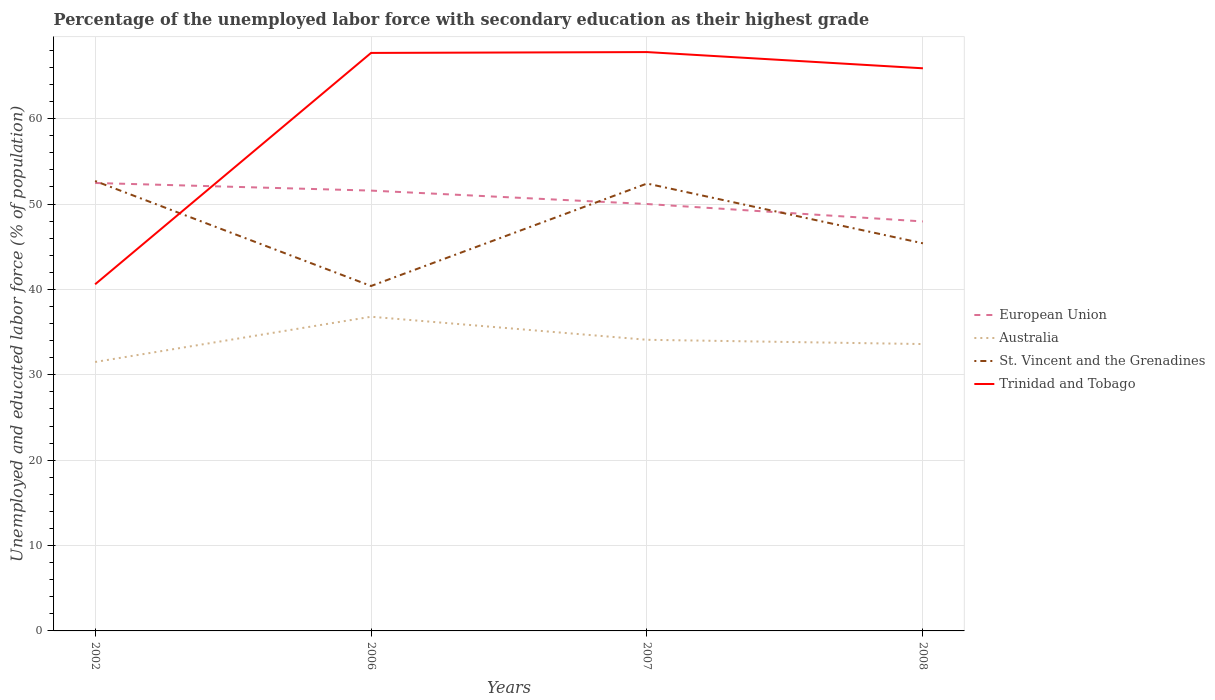Is the number of lines equal to the number of legend labels?
Ensure brevity in your answer.  Yes. Across all years, what is the maximum percentage of the unemployed labor force with secondary education in Australia?
Your answer should be very brief. 31.5. What is the total percentage of the unemployed labor force with secondary education in Trinidad and Tobago in the graph?
Offer a terse response. -27.2. What is the difference between the highest and the second highest percentage of the unemployed labor force with secondary education in Trinidad and Tobago?
Your answer should be compact. 27.2. What is the difference between the highest and the lowest percentage of the unemployed labor force with secondary education in Australia?
Ensure brevity in your answer.  2. Are the values on the major ticks of Y-axis written in scientific E-notation?
Offer a terse response. No. Does the graph contain any zero values?
Provide a succinct answer. No. Does the graph contain grids?
Provide a short and direct response. Yes. Where does the legend appear in the graph?
Your answer should be very brief. Center right. How many legend labels are there?
Offer a terse response. 4. How are the legend labels stacked?
Your answer should be very brief. Vertical. What is the title of the graph?
Your answer should be very brief. Percentage of the unemployed labor force with secondary education as their highest grade. Does "Iran" appear as one of the legend labels in the graph?
Offer a very short reply. No. What is the label or title of the Y-axis?
Your response must be concise. Unemployed and educated labor force (% of population). What is the Unemployed and educated labor force (% of population) of European Union in 2002?
Offer a very short reply. 52.47. What is the Unemployed and educated labor force (% of population) in Australia in 2002?
Provide a succinct answer. 31.5. What is the Unemployed and educated labor force (% of population) in St. Vincent and the Grenadines in 2002?
Provide a short and direct response. 52.7. What is the Unemployed and educated labor force (% of population) in Trinidad and Tobago in 2002?
Provide a succinct answer. 40.6. What is the Unemployed and educated labor force (% of population) of European Union in 2006?
Provide a short and direct response. 51.57. What is the Unemployed and educated labor force (% of population) in Australia in 2006?
Give a very brief answer. 36.8. What is the Unemployed and educated labor force (% of population) in St. Vincent and the Grenadines in 2006?
Keep it short and to the point. 40.4. What is the Unemployed and educated labor force (% of population) of Trinidad and Tobago in 2006?
Your answer should be compact. 67.7. What is the Unemployed and educated labor force (% of population) of European Union in 2007?
Your answer should be very brief. 50. What is the Unemployed and educated labor force (% of population) of Australia in 2007?
Provide a succinct answer. 34.1. What is the Unemployed and educated labor force (% of population) of St. Vincent and the Grenadines in 2007?
Offer a terse response. 52.4. What is the Unemployed and educated labor force (% of population) in Trinidad and Tobago in 2007?
Give a very brief answer. 67.8. What is the Unemployed and educated labor force (% of population) in European Union in 2008?
Offer a terse response. 47.96. What is the Unemployed and educated labor force (% of population) in Australia in 2008?
Make the answer very short. 33.6. What is the Unemployed and educated labor force (% of population) of St. Vincent and the Grenadines in 2008?
Your answer should be compact. 45.4. What is the Unemployed and educated labor force (% of population) in Trinidad and Tobago in 2008?
Your response must be concise. 65.9. Across all years, what is the maximum Unemployed and educated labor force (% of population) of European Union?
Keep it short and to the point. 52.47. Across all years, what is the maximum Unemployed and educated labor force (% of population) in Australia?
Your response must be concise. 36.8. Across all years, what is the maximum Unemployed and educated labor force (% of population) in St. Vincent and the Grenadines?
Provide a succinct answer. 52.7. Across all years, what is the maximum Unemployed and educated labor force (% of population) in Trinidad and Tobago?
Provide a succinct answer. 67.8. Across all years, what is the minimum Unemployed and educated labor force (% of population) in European Union?
Ensure brevity in your answer.  47.96. Across all years, what is the minimum Unemployed and educated labor force (% of population) of Australia?
Offer a very short reply. 31.5. Across all years, what is the minimum Unemployed and educated labor force (% of population) of St. Vincent and the Grenadines?
Offer a very short reply. 40.4. Across all years, what is the minimum Unemployed and educated labor force (% of population) in Trinidad and Tobago?
Your response must be concise. 40.6. What is the total Unemployed and educated labor force (% of population) in European Union in the graph?
Your response must be concise. 202. What is the total Unemployed and educated labor force (% of population) in Australia in the graph?
Make the answer very short. 136. What is the total Unemployed and educated labor force (% of population) of St. Vincent and the Grenadines in the graph?
Your answer should be very brief. 190.9. What is the total Unemployed and educated labor force (% of population) of Trinidad and Tobago in the graph?
Ensure brevity in your answer.  242. What is the difference between the Unemployed and educated labor force (% of population) in European Union in 2002 and that in 2006?
Offer a very short reply. 0.89. What is the difference between the Unemployed and educated labor force (% of population) in Trinidad and Tobago in 2002 and that in 2006?
Your answer should be compact. -27.1. What is the difference between the Unemployed and educated labor force (% of population) of European Union in 2002 and that in 2007?
Keep it short and to the point. 2.46. What is the difference between the Unemployed and educated labor force (% of population) in Trinidad and Tobago in 2002 and that in 2007?
Give a very brief answer. -27.2. What is the difference between the Unemployed and educated labor force (% of population) of European Union in 2002 and that in 2008?
Your response must be concise. 4.5. What is the difference between the Unemployed and educated labor force (% of population) in Australia in 2002 and that in 2008?
Offer a very short reply. -2.1. What is the difference between the Unemployed and educated labor force (% of population) in Trinidad and Tobago in 2002 and that in 2008?
Offer a very short reply. -25.3. What is the difference between the Unemployed and educated labor force (% of population) in European Union in 2006 and that in 2007?
Make the answer very short. 1.57. What is the difference between the Unemployed and educated labor force (% of population) of Australia in 2006 and that in 2007?
Ensure brevity in your answer.  2.7. What is the difference between the Unemployed and educated labor force (% of population) in Trinidad and Tobago in 2006 and that in 2007?
Your answer should be very brief. -0.1. What is the difference between the Unemployed and educated labor force (% of population) of European Union in 2006 and that in 2008?
Provide a short and direct response. 3.61. What is the difference between the Unemployed and educated labor force (% of population) of Australia in 2006 and that in 2008?
Offer a terse response. 3.2. What is the difference between the Unemployed and educated labor force (% of population) of European Union in 2007 and that in 2008?
Offer a terse response. 2.04. What is the difference between the Unemployed and educated labor force (% of population) of Australia in 2007 and that in 2008?
Your answer should be very brief. 0.5. What is the difference between the Unemployed and educated labor force (% of population) of Trinidad and Tobago in 2007 and that in 2008?
Offer a very short reply. 1.9. What is the difference between the Unemployed and educated labor force (% of population) of European Union in 2002 and the Unemployed and educated labor force (% of population) of Australia in 2006?
Offer a terse response. 15.67. What is the difference between the Unemployed and educated labor force (% of population) in European Union in 2002 and the Unemployed and educated labor force (% of population) in St. Vincent and the Grenadines in 2006?
Your response must be concise. 12.07. What is the difference between the Unemployed and educated labor force (% of population) in European Union in 2002 and the Unemployed and educated labor force (% of population) in Trinidad and Tobago in 2006?
Provide a succinct answer. -15.23. What is the difference between the Unemployed and educated labor force (% of population) of Australia in 2002 and the Unemployed and educated labor force (% of population) of St. Vincent and the Grenadines in 2006?
Keep it short and to the point. -8.9. What is the difference between the Unemployed and educated labor force (% of population) of Australia in 2002 and the Unemployed and educated labor force (% of population) of Trinidad and Tobago in 2006?
Give a very brief answer. -36.2. What is the difference between the Unemployed and educated labor force (% of population) of St. Vincent and the Grenadines in 2002 and the Unemployed and educated labor force (% of population) of Trinidad and Tobago in 2006?
Offer a very short reply. -15. What is the difference between the Unemployed and educated labor force (% of population) of European Union in 2002 and the Unemployed and educated labor force (% of population) of Australia in 2007?
Your answer should be very brief. 18.37. What is the difference between the Unemployed and educated labor force (% of population) in European Union in 2002 and the Unemployed and educated labor force (% of population) in St. Vincent and the Grenadines in 2007?
Your answer should be compact. 0.07. What is the difference between the Unemployed and educated labor force (% of population) in European Union in 2002 and the Unemployed and educated labor force (% of population) in Trinidad and Tobago in 2007?
Ensure brevity in your answer.  -15.33. What is the difference between the Unemployed and educated labor force (% of population) in Australia in 2002 and the Unemployed and educated labor force (% of population) in St. Vincent and the Grenadines in 2007?
Offer a very short reply. -20.9. What is the difference between the Unemployed and educated labor force (% of population) in Australia in 2002 and the Unemployed and educated labor force (% of population) in Trinidad and Tobago in 2007?
Your answer should be very brief. -36.3. What is the difference between the Unemployed and educated labor force (% of population) in St. Vincent and the Grenadines in 2002 and the Unemployed and educated labor force (% of population) in Trinidad and Tobago in 2007?
Offer a very short reply. -15.1. What is the difference between the Unemployed and educated labor force (% of population) in European Union in 2002 and the Unemployed and educated labor force (% of population) in Australia in 2008?
Your answer should be compact. 18.87. What is the difference between the Unemployed and educated labor force (% of population) in European Union in 2002 and the Unemployed and educated labor force (% of population) in St. Vincent and the Grenadines in 2008?
Your answer should be very brief. 7.07. What is the difference between the Unemployed and educated labor force (% of population) in European Union in 2002 and the Unemployed and educated labor force (% of population) in Trinidad and Tobago in 2008?
Ensure brevity in your answer.  -13.43. What is the difference between the Unemployed and educated labor force (% of population) of Australia in 2002 and the Unemployed and educated labor force (% of population) of St. Vincent and the Grenadines in 2008?
Provide a short and direct response. -13.9. What is the difference between the Unemployed and educated labor force (% of population) of Australia in 2002 and the Unemployed and educated labor force (% of population) of Trinidad and Tobago in 2008?
Make the answer very short. -34.4. What is the difference between the Unemployed and educated labor force (% of population) of St. Vincent and the Grenadines in 2002 and the Unemployed and educated labor force (% of population) of Trinidad and Tobago in 2008?
Your answer should be very brief. -13.2. What is the difference between the Unemployed and educated labor force (% of population) of European Union in 2006 and the Unemployed and educated labor force (% of population) of Australia in 2007?
Your answer should be compact. 17.47. What is the difference between the Unemployed and educated labor force (% of population) of European Union in 2006 and the Unemployed and educated labor force (% of population) of St. Vincent and the Grenadines in 2007?
Provide a short and direct response. -0.83. What is the difference between the Unemployed and educated labor force (% of population) in European Union in 2006 and the Unemployed and educated labor force (% of population) in Trinidad and Tobago in 2007?
Your response must be concise. -16.23. What is the difference between the Unemployed and educated labor force (% of population) of Australia in 2006 and the Unemployed and educated labor force (% of population) of St. Vincent and the Grenadines in 2007?
Your answer should be very brief. -15.6. What is the difference between the Unemployed and educated labor force (% of population) of Australia in 2006 and the Unemployed and educated labor force (% of population) of Trinidad and Tobago in 2007?
Keep it short and to the point. -31. What is the difference between the Unemployed and educated labor force (% of population) of St. Vincent and the Grenadines in 2006 and the Unemployed and educated labor force (% of population) of Trinidad and Tobago in 2007?
Your answer should be very brief. -27.4. What is the difference between the Unemployed and educated labor force (% of population) in European Union in 2006 and the Unemployed and educated labor force (% of population) in Australia in 2008?
Provide a succinct answer. 17.97. What is the difference between the Unemployed and educated labor force (% of population) in European Union in 2006 and the Unemployed and educated labor force (% of population) in St. Vincent and the Grenadines in 2008?
Provide a short and direct response. 6.17. What is the difference between the Unemployed and educated labor force (% of population) in European Union in 2006 and the Unemployed and educated labor force (% of population) in Trinidad and Tobago in 2008?
Offer a very short reply. -14.33. What is the difference between the Unemployed and educated labor force (% of population) of Australia in 2006 and the Unemployed and educated labor force (% of population) of Trinidad and Tobago in 2008?
Ensure brevity in your answer.  -29.1. What is the difference between the Unemployed and educated labor force (% of population) in St. Vincent and the Grenadines in 2006 and the Unemployed and educated labor force (% of population) in Trinidad and Tobago in 2008?
Give a very brief answer. -25.5. What is the difference between the Unemployed and educated labor force (% of population) of European Union in 2007 and the Unemployed and educated labor force (% of population) of Australia in 2008?
Offer a very short reply. 16.4. What is the difference between the Unemployed and educated labor force (% of population) in European Union in 2007 and the Unemployed and educated labor force (% of population) in St. Vincent and the Grenadines in 2008?
Your answer should be compact. 4.6. What is the difference between the Unemployed and educated labor force (% of population) of European Union in 2007 and the Unemployed and educated labor force (% of population) of Trinidad and Tobago in 2008?
Offer a very short reply. -15.9. What is the difference between the Unemployed and educated labor force (% of population) in Australia in 2007 and the Unemployed and educated labor force (% of population) in St. Vincent and the Grenadines in 2008?
Your answer should be compact. -11.3. What is the difference between the Unemployed and educated labor force (% of population) in Australia in 2007 and the Unemployed and educated labor force (% of population) in Trinidad and Tobago in 2008?
Give a very brief answer. -31.8. What is the difference between the Unemployed and educated labor force (% of population) of St. Vincent and the Grenadines in 2007 and the Unemployed and educated labor force (% of population) of Trinidad and Tobago in 2008?
Ensure brevity in your answer.  -13.5. What is the average Unemployed and educated labor force (% of population) of European Union per year?
Offer a terse response. 50.5. What is the average Unemployed and educated labor force (% of population) of St. Vincent and the Grenadines per year?
Make the answer very short. 47.73. What is the average Unemployed and educated labor force (% of population) of Trinidad and Tobago per year?
Offer a terse response. 60.5. In the year 2002, what is the difference between the Unemployed and educated labor force (% of population) in European Union and Unemployed and educated labor force (% of population) in Australia?
Give a very brief answer. 20.97. In the year 2002, what is the difference between the Unemployed and educated labor force (% of population) in European Union and Unemployed and educated labor force (% of population) in St. Vincent and the Grenadines?
Provide a succinct answer. -0.23. In the year 2002, what is the difference between the Unemployed and educated labor force (% of population) in European Union and Unemployed and educated labor force (% of population) in Trinidad and Tobago?
Ensure brevity in your answer.  11.87. In the year 2002, what is the difference between the Unemployed and educated labor force (% of population) of Australia and Unemployed and educated labor force (% of population) of St. Vincent and the Grenadines?
Ensure brevity in your answer.  -21.2. In the year 2002, what is the difference between the Unemployed and educated labor force (% of population) of St. Vincent and the Grenadines and Unemployed and educated labor force (% of population) of Trinidad and Tobago?
Give a very brief answer. 12.1. In the year 2006, what is the difference between the Unemployed and educated labor force (% of population) in European Union and Unemployed and educated labor force (% of population) in Australia?
Your answer should be very brief. 14.77. In the year 2006, what is the difference between the Unemployed and educated labor force (% of population) of European Union and Unemployed and educated labor force (% of population) of St. Vincent and the Grenadines?
Your response must be concise. 11.17. In the year 2006, what is the difference between the Unemployed and educated labor force (% of population) of European Union and Unemployed and educated labor force (% of population) of Trinidad and Tobago?
Ensure brevity in your answer.  -16.13. In the year 2006, what is the difference between the Unemployed and educated labor force (% of population) in Australia and Unemployed and educated labor force (% of population) in Trinidad and Tobago?
Your response must be concise. -30.9. In the year 2006, what is the difference between the Unemployed and educated labor force (% of population) in St. Vincent and the Grenadines and Unemployed and educated labor force (% of population) in Trinidad and Tobago?
Offer a very short reply. -27.3. In the year 2007, what is the difference between the Unemployed and educated labor force (% of population) of European Union and Unemployed and educated labor force (% of population) of Australia?
Give a very brief answer. 15.9. In the year 2007, what is the difference between the Unemployed and educated labor force (% of population) of European Union and Unemployed and educated labor force (% of population) of St. Vincent and the Grenadines?
Offer a very short reply. -2.4. In the year 2007, what is the difference between the Unemployed and educated labor force (% of population) in European Union and Unemployed and educated labor force (% of population) in Trinidad and Tobago?
Provide a succinct answer. -17.8. In the year 2007, what is the difference between the Unemployed and educated labor force (% of population) in Australia and Unemployed and educated labor force (% of population) in St. Vincent and the Grenadines?
Your response must be concise. -18.3. In the year 2007, what is the difference between the Unemployed and educated labor force (% of population) in Australia and Unemployed and educated labor force (% of population) in Trinidad and Tobago?
Give a very brief answer. -33.7. In the year 2007, what is the difference between the Unemployed and educated labor force (% of population) of St. Vincent and the Grenadines and Unemployed and educated labor force (% of population) of Trinidad and Tobago?
Make the answer very short. -15.4. In the year 2008, what is the difference between the Unemployed and educated labor force (% of population) in European Union and Unemployed and educated labor force (% of population) in Australia?
Ensure brevity in your answer.  14.36. In the year 2008, what is the difference between the Unemployed and educated labor force (% of population) in European Union and Unemployed and educated labor force (% of population) in St. Vincent and the Grenadines?
Your answer should be very brief. 2.56. In the year 2008, what is the difference between the Unemployed and educated labor force (% of population) of European Union and Unemployed and educated labor force (% of population) of Trinidad and Tobago?
Your answer should be very brief. -17.94. In the year 2008, what is the difference between the Unemployed and educated labor force (% of population) of Australia and Unemployed and educated labor force (% of population) of St. Vincent and the Grenadines?
Keep it short and to the point. -11.8. In the year 2008, what is the difference between the Unemployed and educated labor force (% of population) in Australia and Unemployed and educated labor force (% of population) in Trinidad and Tobago?
Ensure brevity in your answer.  -32.3. In the year 2008, what is the difference between the Unemployed and educated labor force (% of population) of St. Vincent and the Grenadines and Unemployed and educated labor force (% of population) of Trinidad and Tobago?
Your answer should be very brief. -20.5. What is the ratio of the Unemployed and educated labor force (% of population) of European Union in 2002 to that in 2006?
Your answer should be compact. 1.02. What is the ratio of the Unemployed and educated labor force (% of population) in Australia in 2002 to that in 2006?
Make the answer very short. 0.86. What is the ratio of the Unemployed and educated labor force (% of population) in St. Vincent and the Grenadines in 2002 to that in 2006?
Offer a very short reply. 1.3. What is the ratio of the Unemployed and educated labor force (% of population) in Trinidad and Tobago in 2002 to that in 2006?
Your answer should be compact. 0.6. What is the ratio of the Unemployed and educated labor force (% of population) in European Union in 2002 to that in 2007?
Offer a terse response. 1.05. What is the ratio of the Unemployed and educated labor force (% of population) in Australia in 2002 to that in 2007?
Offer a very short reply. 0.92. What is the ratio of the Unemployed and educated labor force (% of population) in St. Vincent and the Grenadines in 2002 to that in 2007?
Provide a succinct answer. 1.01. What is the ratio of the Unemployed and educated labor force (% of population) in Trinidad and Tobago in 2002 to that in 2007?
Make the answer very short. 0.6. What is the ratio of the Unemployed and educated labor force (% of population) in European Union in 2002 to that in 2008?
Make the answer very short. 1.09. What is the ratio of the Unemployed and educated labor force (% of population) in Australia in 2002 to that in 2008?
Make the answer very short. 0.94. What is the ratio of the Unemployed and educated labor force (% of population) in St. Vincent and the Grenadines in 2002 to that in 2008?
Your answer should be very brief. 1.16. What is the ratio of the Unemployed and educated labor force (% of population) in Trinidad and Tobago in 2002 to that in 2008?
Provide a short and direct response. 0.62. What is the ratio of the Unemployed and educated labor force (% of population) in European Union in 2006 to that in 2007?
Offer a very short reply. 1.03. What is the ratio of the Unemployed and educated labor force (% of population) of Australia in 2006 to that in 2007?
Offer a very short reply. 1.08. What is the ratio of the Unemployed and educated labor force (% of population) of St. Vincent and the Grenadines in 2006 to that in 2007?
Give a very brief answer. 0.77. What is the ratio of the Unemployed and educated labor force (% of population) in European Union in 2006 to that in 2008?
Ensure brevity in your answer.  1.08. What is the ratio of the Unemployed and educated labor force (% of population) in Australia in 2006 to that in 2008?
Keep it short and to the point. 1.1. What is the ratio of the Unemployed and educated labor force (% of population) in St. Vincent and the Grenadines in 2006 to that in 2008?
Ensure brevity in your answer.  0.89. What is the ratio of the Unemployed and educated labor force (% of population) in Trinidad and Tobago in 2006 to that in 2008?
Your answer should be very brief. 1.03. What is the ratio of the Unemployed and educated labor force (% of population) of European Union in 2007 to that in 2008?
Your answer should be compact. 1.04. What is the ratio of the Unemployed and educated labor force (% of population) of Australia in 2007 to that in 2008?
Your response must be concise. 1.01. What is the ratio of the Unemployed and educated labor force (% of population) in St. Vincent and the Grenadines in 2007 to that in 2008?
Ensure brevity in your answer.  1.15. What is the ratio of the Unemployed and educated labor force (% of population) in Trinidad and Tobago in 2007 to that in 2008?
Ensure brevity in your answer.  1.03. What is the difference between the highest and the second highest Unemployed and educated labor force (% of population) in European Union?
Offer a very short reply. 0.89. What is the difference between the highest and the second highest Unemployed and educated labor force (% of population) in St. Vincent and the Grenadines?
Keep it short and to the point. 0.3. What is the difference between the highest and the lowest Unemployed and educated labor force (% of population) of European Union?
Offer a terse response. 4.5. What is the difference between the highest and the lowest Unemployed and educated labor force (% of population) in Australia?
Provide a succinct answer. 5.3. What is the difference between the highest and the lowest Unemployed and educated labor force (% of population) in St. Vincent and the Grenadines?
Provide a succinct answer. 12.3. What is the difference between the highest and the lowest Unemployed and educated labor force (% of population) in Trinidad and Tobago?
Your response must be concise. 27.2. 